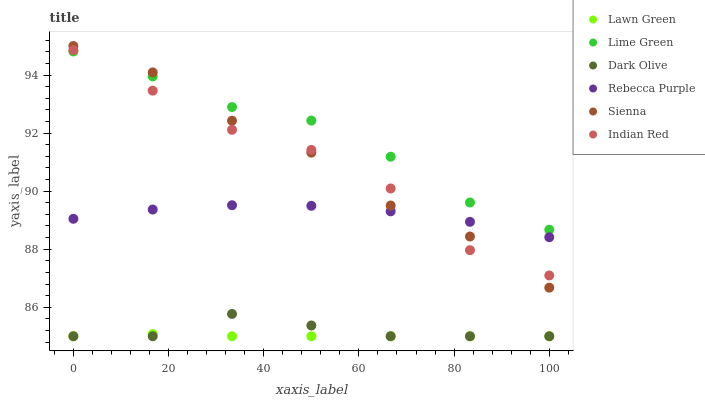Does Lawn Green have the minimum area under the curve?
Answer yes or no. Yes. Does Lime Green have the maximum area under the curve?
Answer yes or no. Yes. Does Dark Olive have the minimum area under the curve?
Answer yes or no. No. Does Dark Olive have the maximum area under the curve?
Answer yes or no. No. Is Lawn Green the smoothest?
Answer yes or no. Yes. Is Sienna the roughest?
Answer yes or no. Yes. Is Dark Olive the smoothest?
Answer yes or no. No. Is Dark Olive the roughest?
Answer yes or no. No. Does Lawn Green have the lowest value?
Answer yes or no. Yes. Does Sienna have the lowest value?
Answer yes or no. No. Does Sienna have the highest value?
Answer yes or no. Yes. Does Dark Olive have the highest value?
Answer yes or no. No. Is Rebecca Purple less than Lime Green?
Answer yes or no. Yes. Is Lime Green greater than Lawn Green?
Answer yes or no. Yes. Does Indian Red intersect Sienna?
Answer yes or no. Yes. Is Indian Red less than Sienna?
Answer yes or no. No. Is Indian Red greater than Sienna?
Answer yes or no. No. Does Rebecca Purple intersect Lime Green?
Answer yes or no. No. 